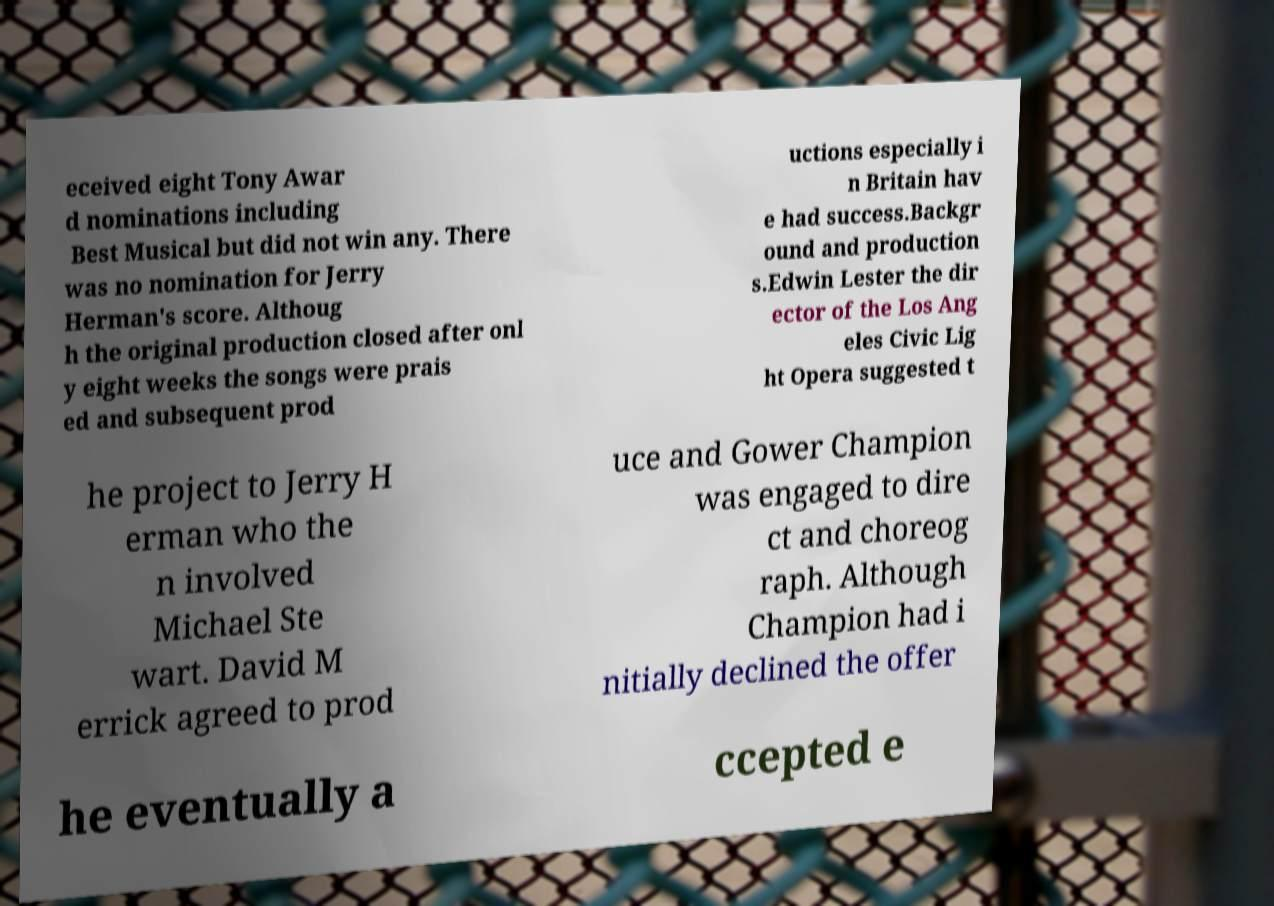For documentation purposes, I need the text within this image transcribed. Could you provide that? eceived eight Tony Awar d nominations including Best Musical but did not win any. There was no nomination for Jerry Herman's score. Althoug h the original production closed after onl y eight weeks the songs were prais ed and subsequent prod uctions especially i n Britain hav e had success.Backgr ound and production s.Edwin Lester the dir ector of the Los Ang eles Civic Lig ht Opera suggested t he project to Jerry H erman who the n involved Michael Ste wart. David M errick agreed to prod uce and Gower Champion was engaged to dire ct and choreog raph. Although Champion had i nitially declined the offer he eventually a ccepted e 